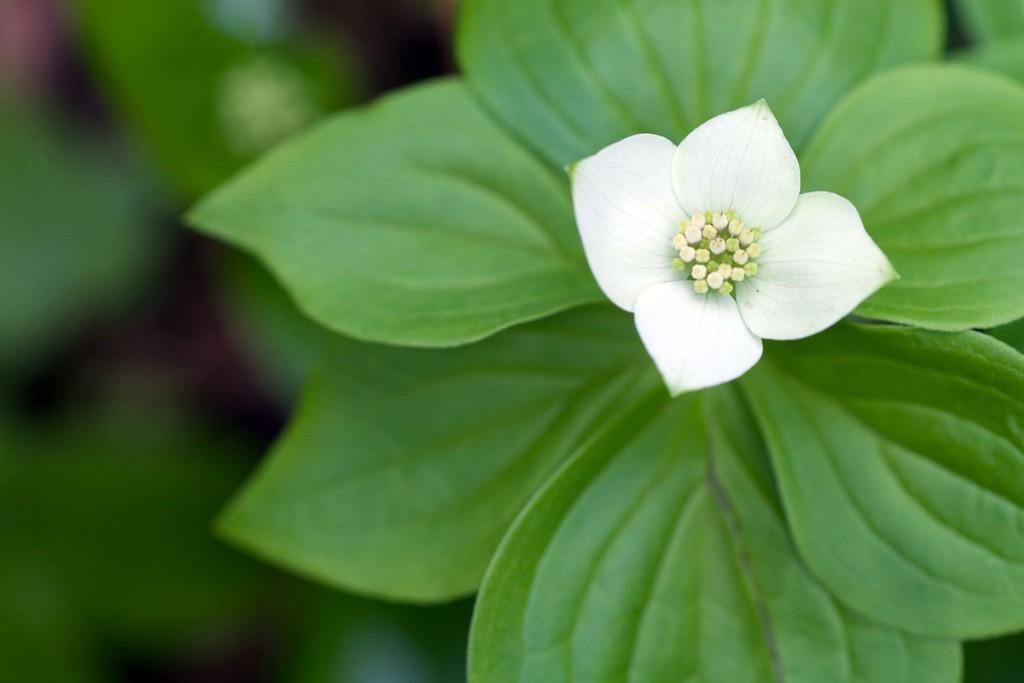What is located in the front of the image? There is a plant in the front of the image. What type of floral element is present in the image? There is a flower in the image. How would you describe the background of the image? The background of the image is blurry. What type of dress is the plant wearing in the image? There is no dress present in the image, as the main subject is a plant. Can you see any hammers or tools in the image? There are no hammers or tools visible in the image. 